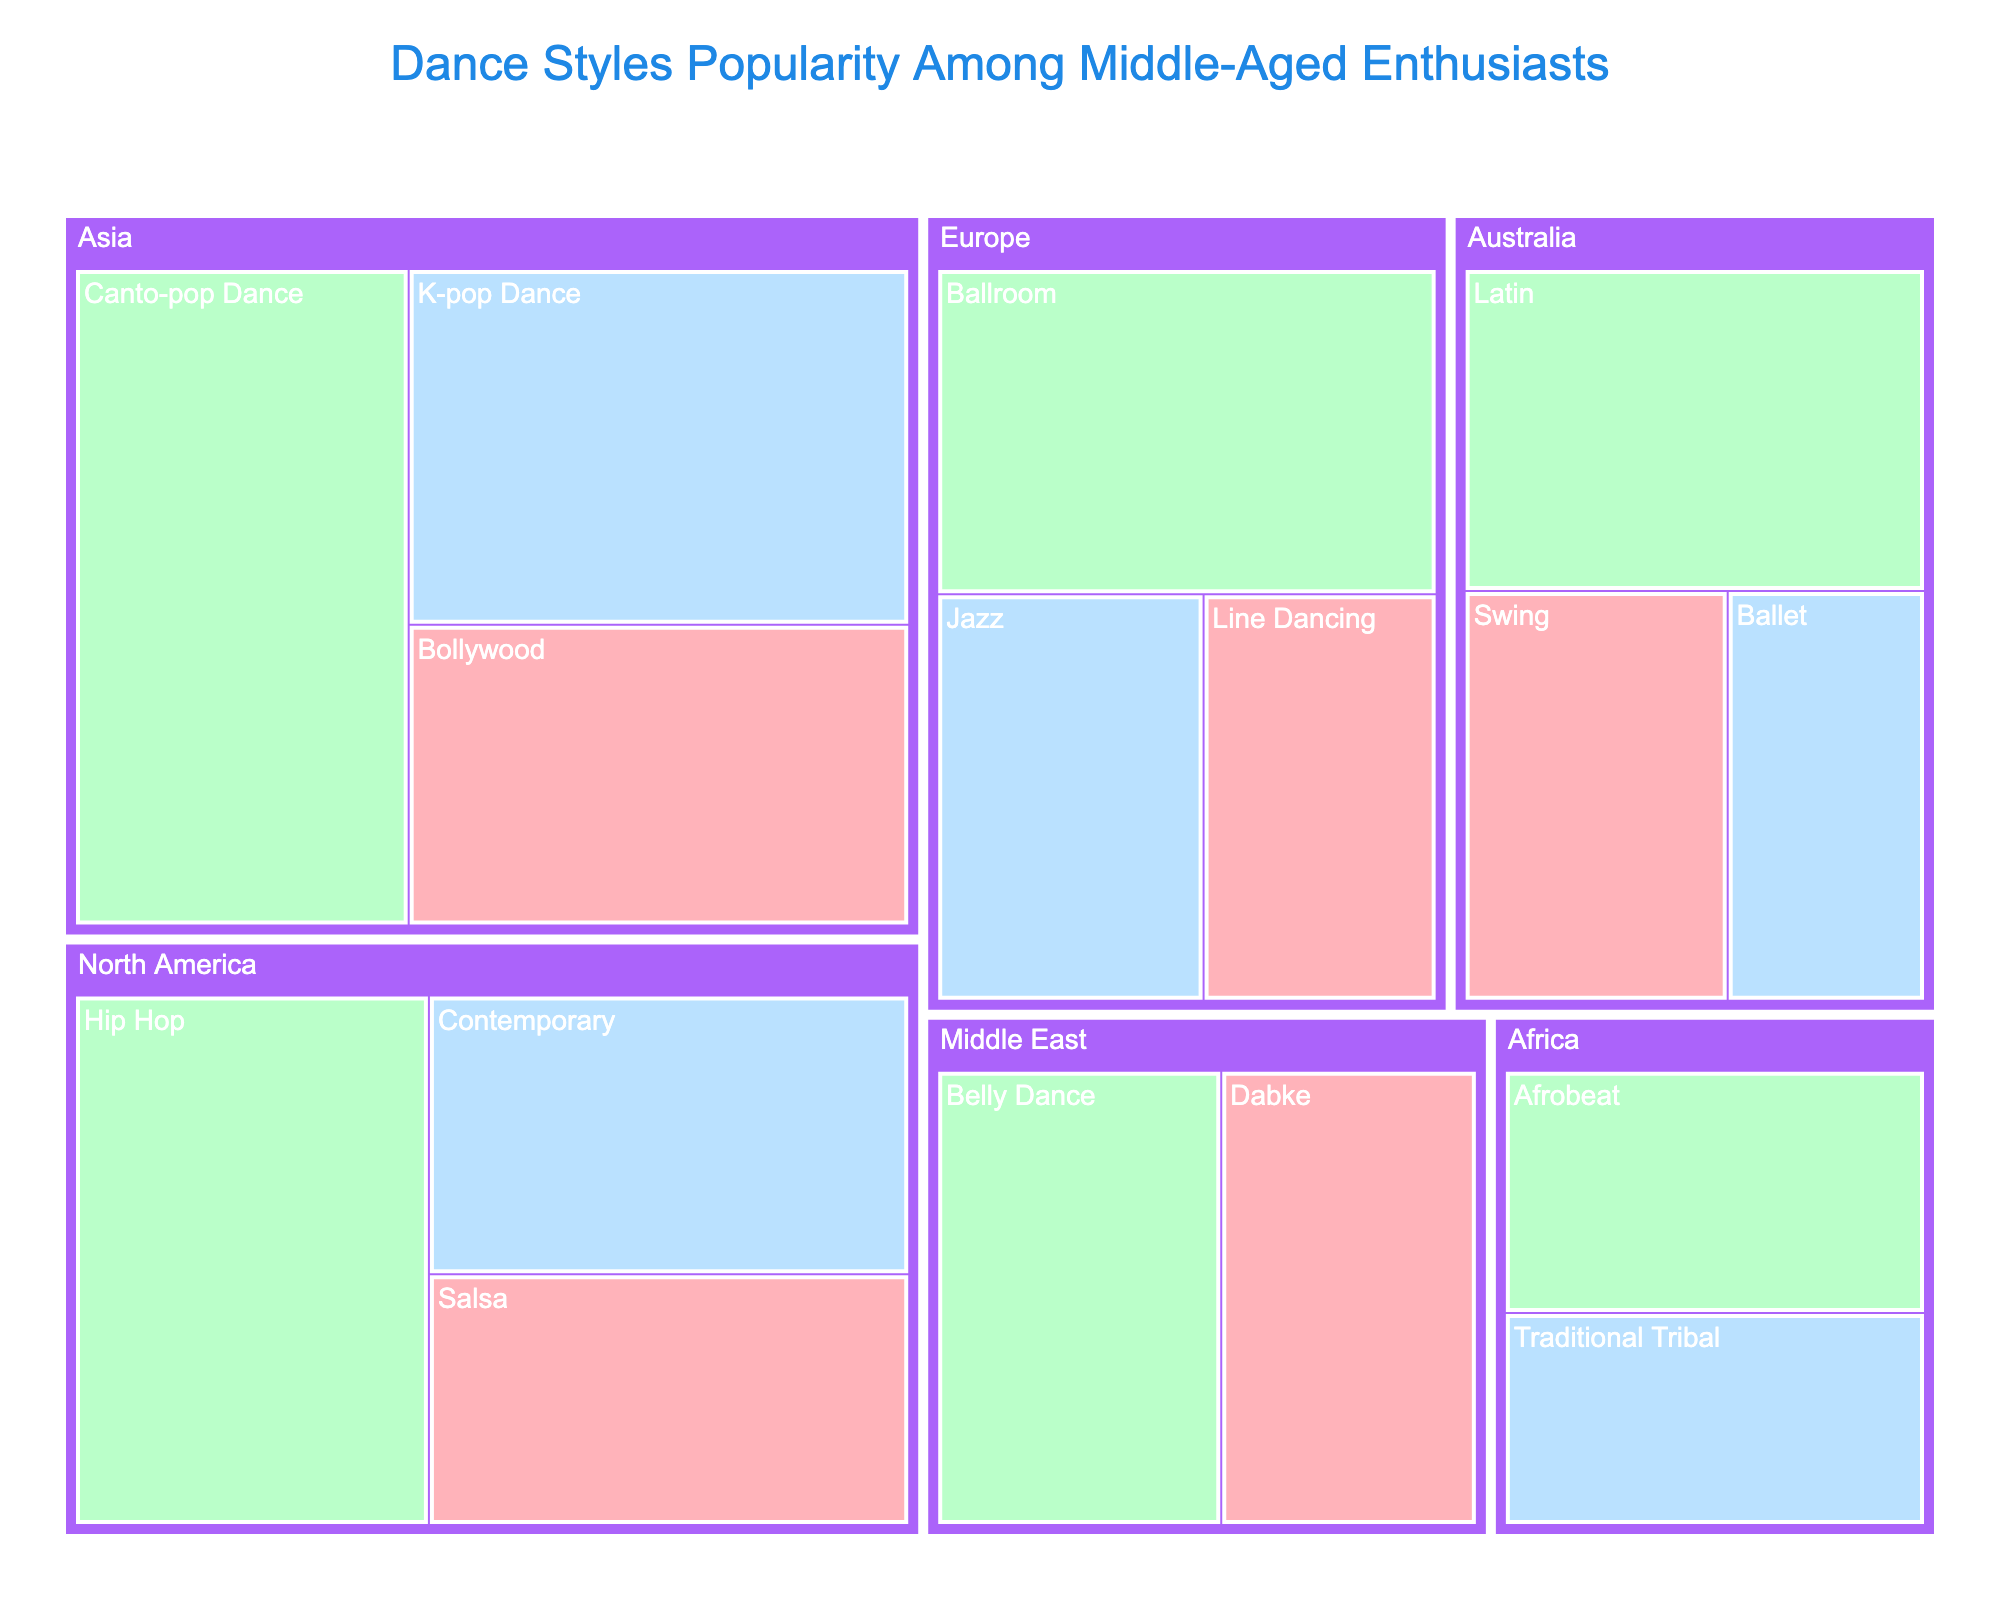What's the title of the figure? The title is typically found at the top of the figure, clearly stating the purpose of the visualization.
Answer: Dance Styles Popularity Among Middle-Aged Enthusiasts What color represents the 'Easy' difficulty level? The legend or color key typically indicates what each color represents. In the figure, 'Easy' is marked with a specific color.
Answer: Light pink (#FFB3BA) Which dance style has the highest popularity in Asia? Identify and locate the region labeled "Asia," then look for the dance style with the largest area within Asia, as size indicates popularity.
Answer: Canto-pop Dance What is the least popular dance style in Australia? Navigate to the Australia region and compare the sizes of the blocks representing dance styles. The smallest block indicates the least popular style.
Answer: Ballet What is the total popularity of all dance styles in North America? Add up the popularity values of all dance styles listed under North America. The values are 70 (Hip Hop), 50 (Contemporary), and 45 (Salsa). 70 + 50 + 45 = 165.
Answer: 165 Which region has the highest cumulative popularity for 'Medium' difficulty dance styles? Sum the popularity of 'Medium' difficulty dance styles in each region and compare.
Answer: Asia Compare the popularity of K-pop Dance and Hip Hop. Which one is more popular? Locate K-pop Dance and Hip Hop in their respective regions and compare their popularity values.
Answer: K-pop Dance Which region has the most diverse range of dance styles in terms of difficulty level? Count the number of unique difficulty levels under each region and identify the region with all three ("Easy," "Medium," "Hard").
Answer: North America What is the average popularity of the dance styles in Europe? For Europe, add the popularity values of Ballroom (60), Jazz (40), and Line Dancing (35), then divide by the number of styles. (60 + 40 + 35) / 3 = 45
Answer: 45 Which dance style from the Middle East has the highest popularity? Compare the sizes of the dance styles under the Middle East. The largest one represents the highest popularity.
Answer: Belly Dance 